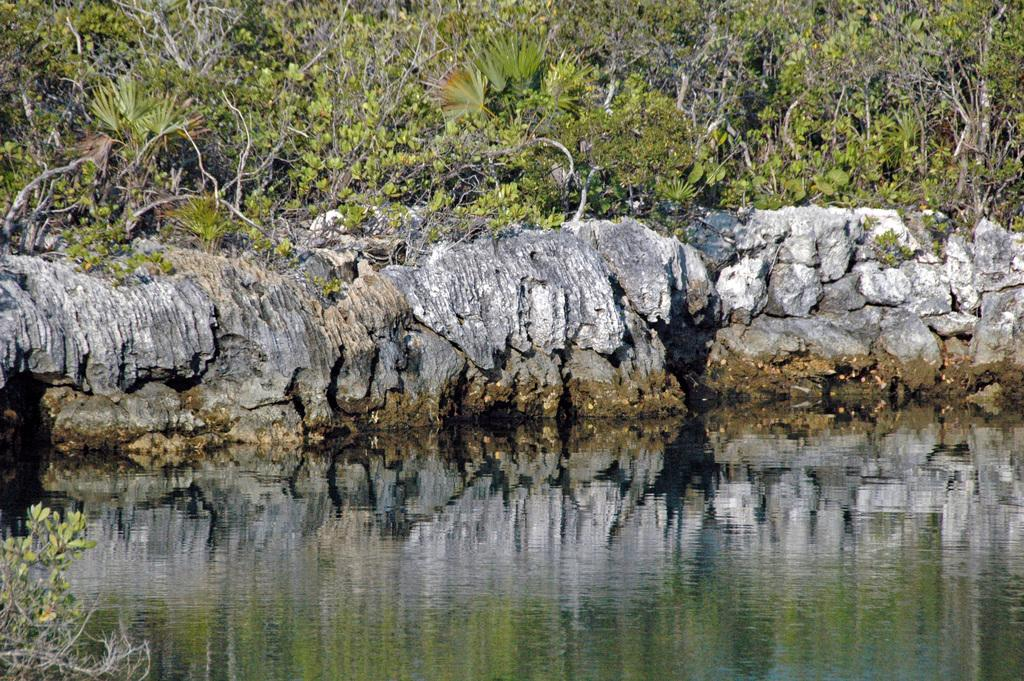What type of natural elements can be seen in the image? There are rocks and trees visible in the image. What is the terrain like in the image? The terrain includes rocks and trees. What can be seen at the bottom of the image? There is water visible at the bottom of the image. How many pies are balanced on the head of the person in the image? There is no person present in the image, and therefore no pies can be balanced on a head. Can you describe the icicle hanging from the tree in the image? There is no icicle present in the image; it features rocks, trees, and water. 